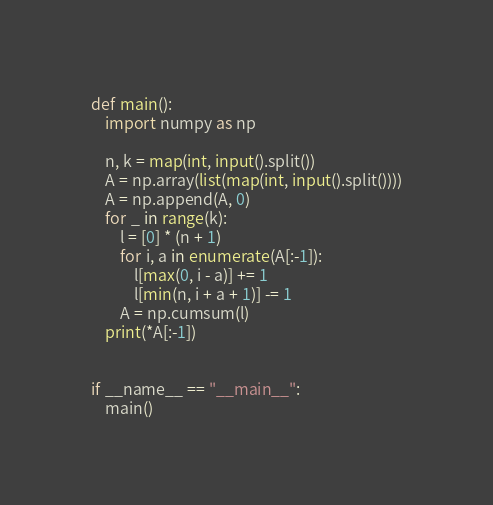<code> <loc_0><loc_0><loc_500><loc_500><_Python_>def main():
    import numpy as np

    n, k = map(int, input().split())
    A = np.array(list(map(int, input().split())))
    A = np.append(A, 0)
    for _ in range(k):
        l = [0] * (n + 1)
        for i, a in enumerate(A[:-1]):
            l[max(0, i - a)] += 1
            l[min(n, i + a + 1)] -= 1
        A = np.cumsum(l)
    print(*A[:-1])


if __name__ == "__main__":
    main()</code> 